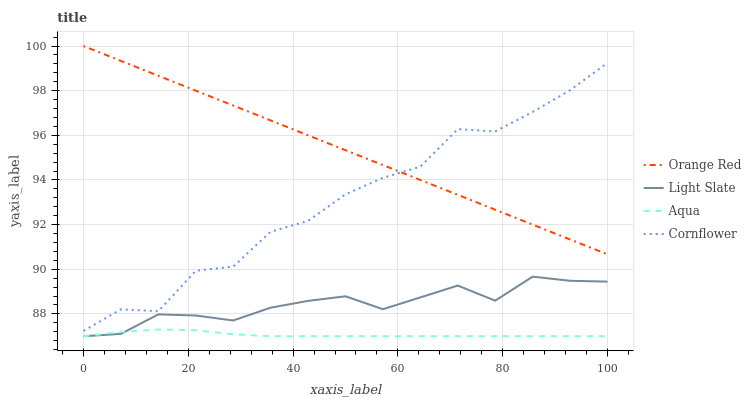Does Aqua have the minimum area under the curve?
Answer yes or no. Yes. Does Orange Red have the maximum area under the curve?
Answer yes or no. Yes. Does Cornflower have the minimum area under the curve?
Answer yes or no. No. Does Cornflower have the maximum area under the curve?
Answer yes or no. No. Is Orange Red the smoothest?
Answer yes or no. Yes. Is Cornflower the roughest?
Answer yes or no. Yes. Is Aqua the smoothest?
Answer yes or no. No. Is Aqua the roughest?
Answer yes or no. No. Does Light Slate have the lowest value?
Answer yes or no. Yes. Does Cornflower have the lowest value?
Answer yes or no. No. Does Orange Red have the highest value?
Answer yes or no. Yes. Does Cornflower have the highest value?
Answer yes or no. No. Is Aqua less than Orange Red?
Answer yes or no. Yes. Is Orange Red greater than Aqua?
Answer yes or no. Yes. Does Light Slate intersect Aqua?
Answer yes or no. Yes. Is Light Slate less than Aqua?
Answer yes or no. No. Is Light Slate greater than Aqua?
Answer yes or no. No. Does Aqua intersect Orange Red?
Answer yes or no. No. 